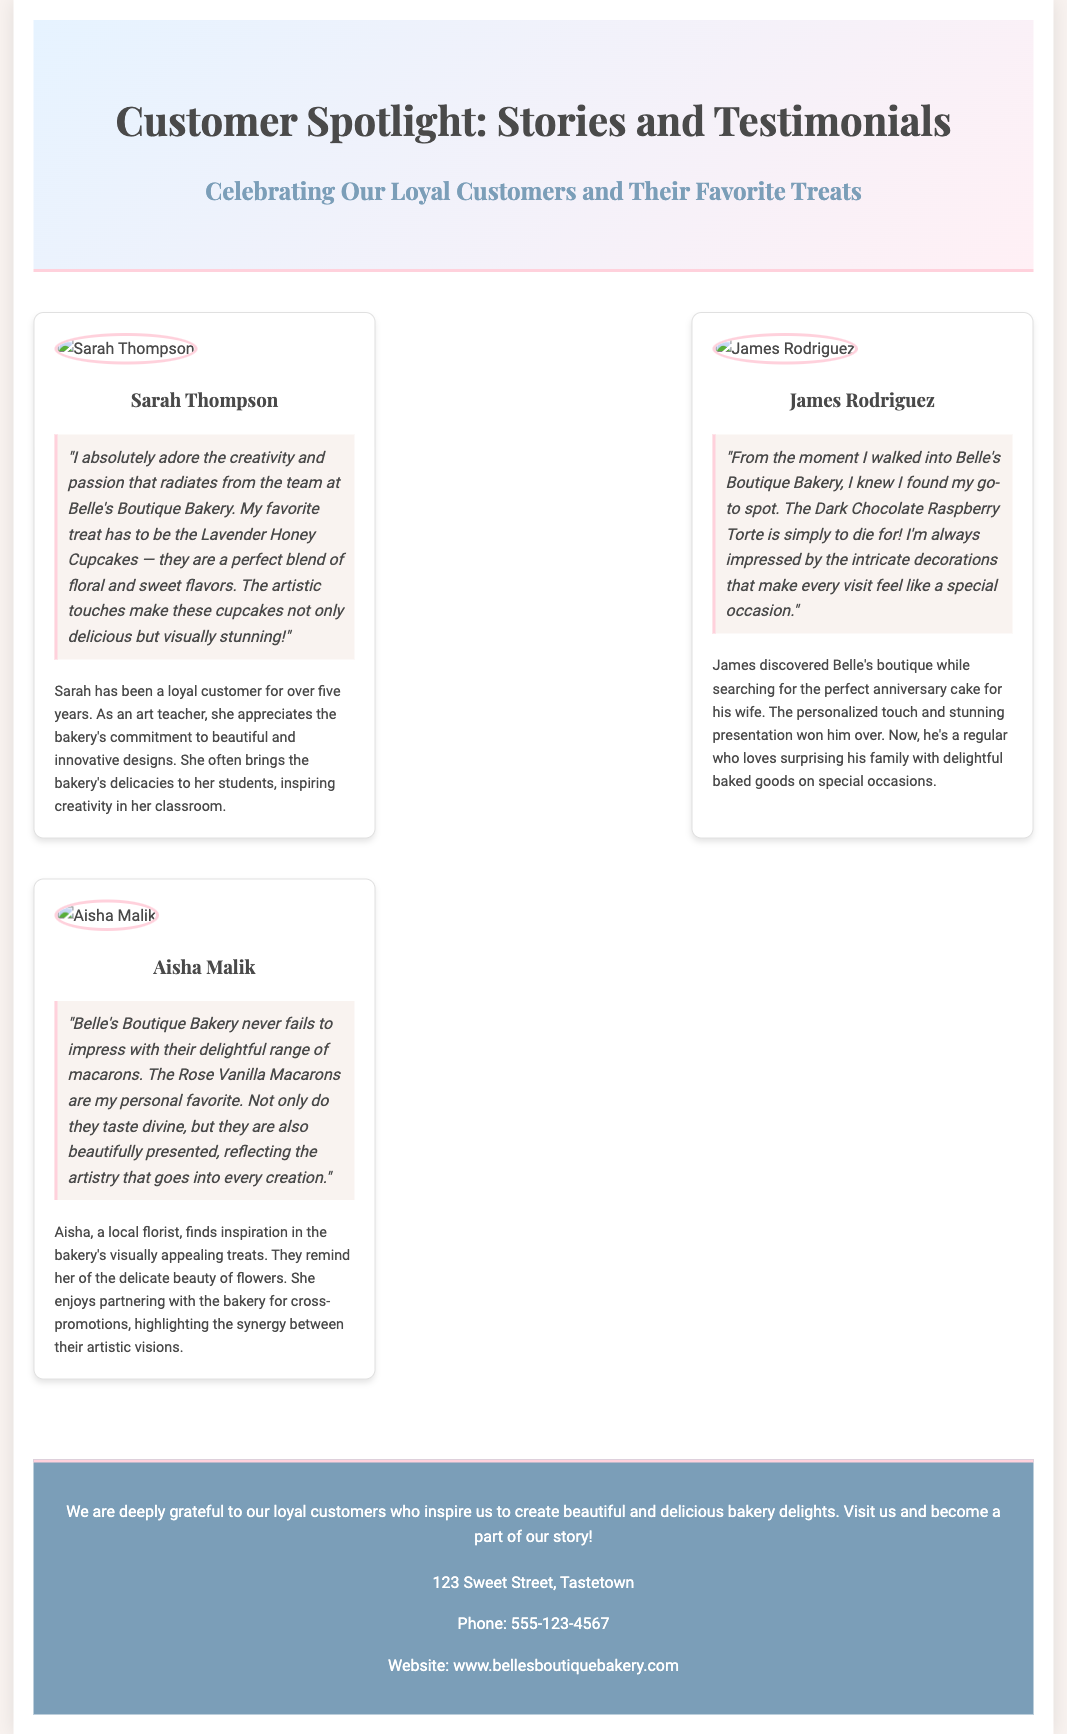What is the name of the bakery? The name of the bakery is clearly mentioned in the header of the document.
Answer: Belle's Boutique Bakery How many featured customers are spotlighted? The document lists three customers in the customer spotlight section.
Answer: Three What is Sarah Thompson's favorite product? Sarah's favorite product is specified in her testimonial section.
Answer: Lavender Honey Cupcakes What profession does Aisha Malik have? Aisha's profession is mentioned in her personal story portion of the document.
Answer: Florist What is the address of Belle's Boutique Bakery? The address is provided in the footer section of the document.
Answer: 123 Sweet Street, Tastetown What dessert did James Rodriguez mention? James mentions a specific dessert he enjoys in his testimonial.
Answer: Dark Chocolate Raspberry Torte Why does Aisha appreciate the bakery's treats? Aisha's appreciation is explained in her story, which outlines her thoughts on aesthetics.
Answer: Delicate beauty of flowers What color is used in the background of the header? The header has a gradient background color which can be identified in the style.
Answer: Light blue to pink gradient 